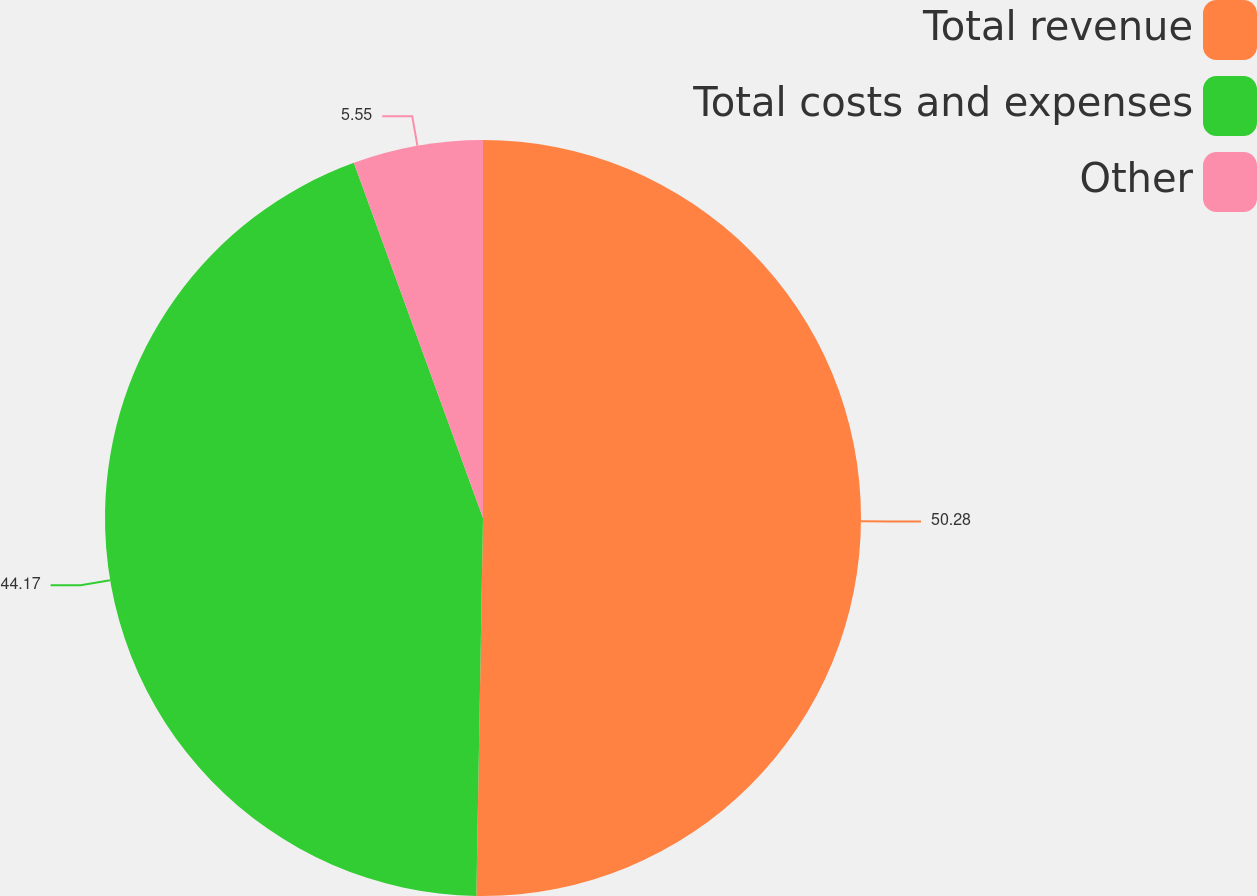Convert chart to OTSL. <chart><loc_0><loc_0><loc_500><loc_500><pie_chart><fcel>Total revenue<fcel>Total costs and expenses<fcel>Other<nl><fcel>50.28%<fcel>44.17%<fcel>5.55%<nl></chart> 